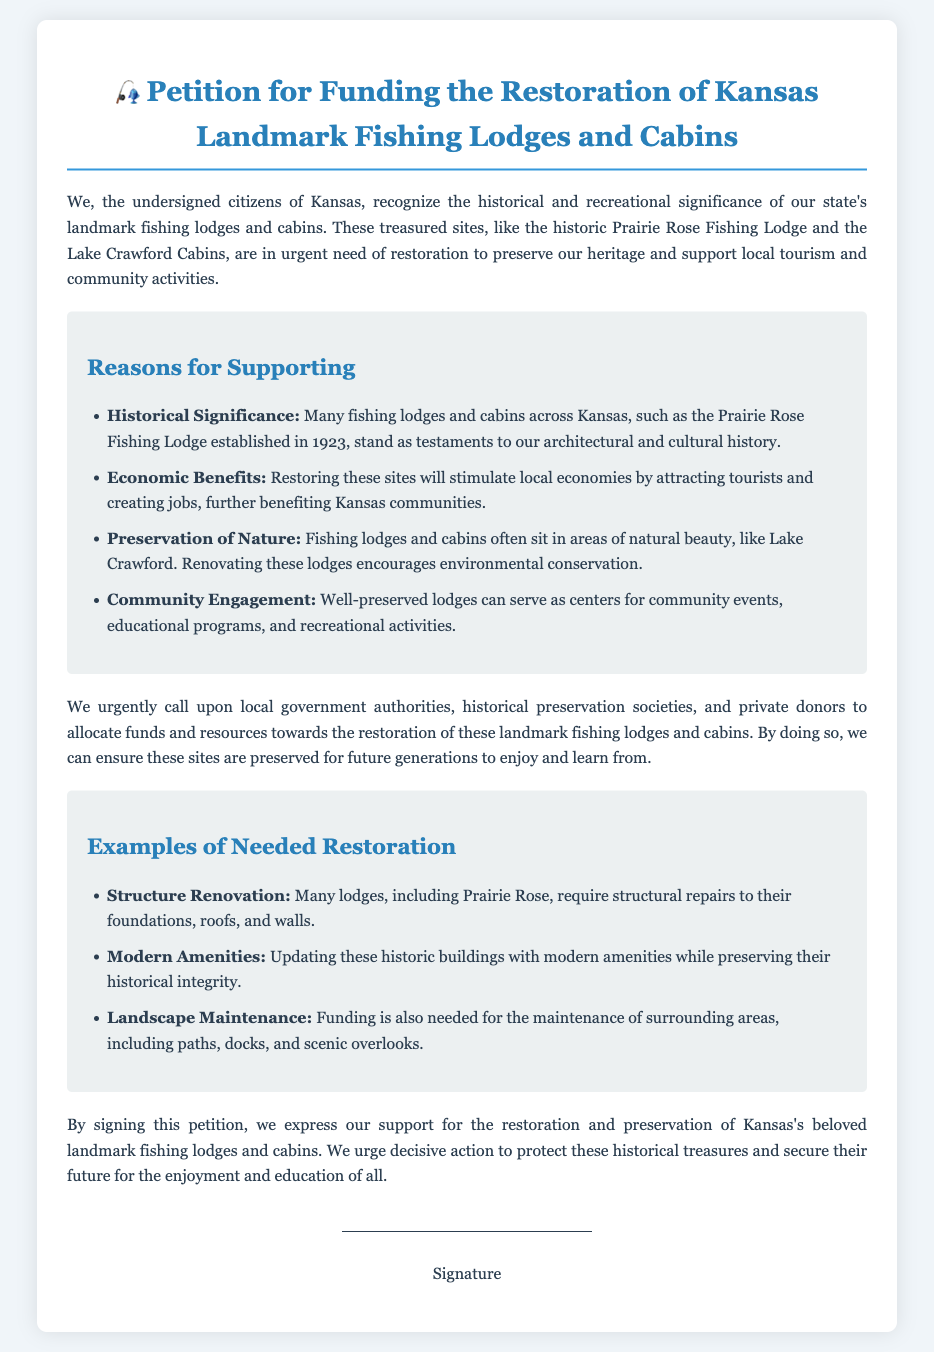What is the title of the petition? The title is clearly mentioned at the top of the document, stating the purpose of the petition.
Answer: Petition for Funding the Restoration of Kansas Landmark Fishing Lodges and Cabins When was the Prairie Rose Fishing Lodge established? The document states the establishment year of the Prairie Rose Fishing Lodge.
Answer: 1923 What is one reason for supporting the restoration? The reasons listed in the document explain the importance of restoring the lodges and cabins.
Answer: Historical Significance What is one example of necessary restoration? The document lists various examples of needed restoration efforts for the lodges.
Answer: Structure Renovation Who is being called upon for funding? The appeal section specifies the entities that should allocate funds for restoration.
Answer: local government authorities What is one benefit of restoring these sites? The document highlights some specific benefits of restoring the fishing lodges and cabins.
Answer: Economic Benefits What type of maintenance is funded for surrounding areas? The document mentions a specific aspect of the maintenance needed for the landscape.
Answer: Landscape Maintenance What does this petition urge? The conclusion provides the main action that the petition asks from the audience.
Answer: decisive action How many areas are listed as reasons for supporting the petition? The document outlines several reasons in a bulleted list for support.
Answer: Four 